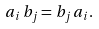<formula> <loc_0><loc_0><loc_500><loc_500>a _ { i } \, b _ { j } = b _ { j } \, a _ { i } .</formula> 